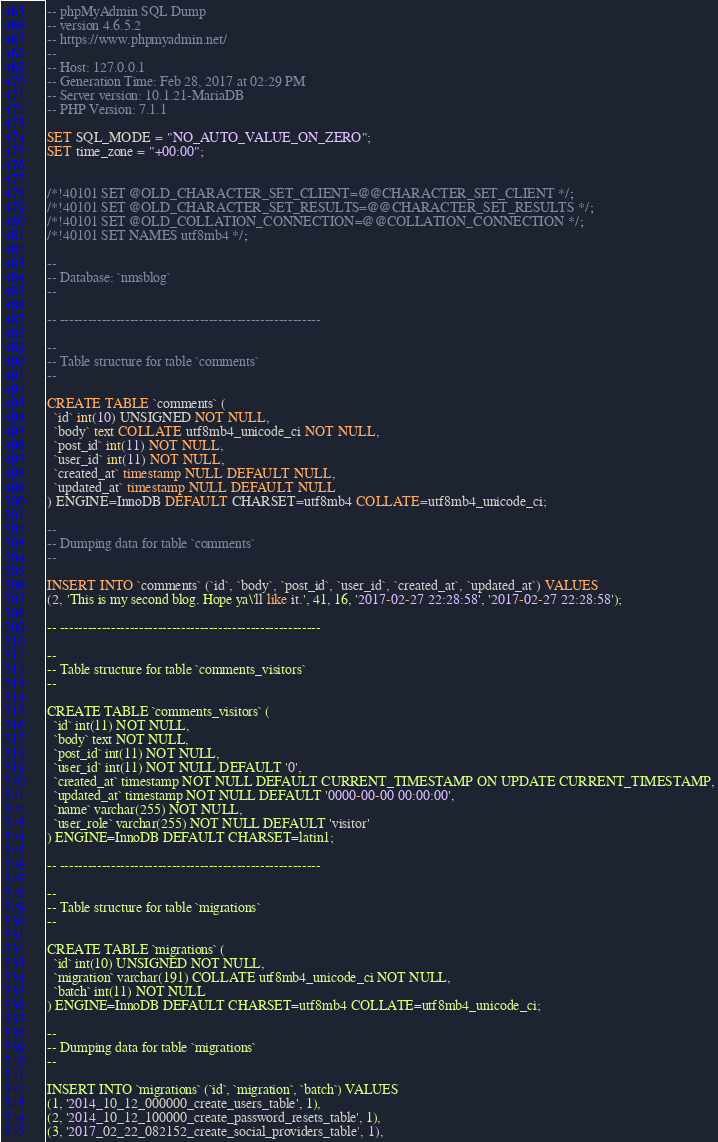Convert code to text. <code><loc_0><loc_0><loc_500><loc_500><_SQL_>-- phpMyAdmin SQL Dump
-- version 4.6.5.2
-- https://www.phpmyadmin.net/
--
-- Host: 127.0.0.1
-- Generation Time: Feb 28, 2017 at 02:29 PM
-- Server version: 10.1.21-MariaDB
-- PHP Version: 7.1.1

SET SQL_MODE = "NO_AUTO_VALUE_ON_ZERO";
SET time_zone = "+00:00";


/*!40101 SET @OLD_CHARACTER_SET_CLIENT=@@CHARACTER_SET_CLIENT */;
/*!40101 SET @OLD_CHARACTER_SET_RESULTS=@@CHARACTER_SET_RESULTS */;
/*!40101 SET @OLD_COLLATION_CONNECTION=@@COLLATION_CONNECTION */;
/*!40101 SET NAMES utf8mb4 */;

--
-- Database: `nmsblog`
--

-- --------------------------------------------------------

--
-- Table structure for table `comments`
--

CREATE TABLE `comments` (
  `id` int(10) UNSIGNED NOT NULL,
  `body` text COLLATE utf8mb4_unicode_ci NOT NULL,
  `post_id` int(11) NOT NULL,
  `user_id` int(11) NOT NULL,
  `created_at` timestamp NULL DEFAULT NULL,
  `updated_at` timestamp NULL DEFAULT NULL
) ENGINE=InnoDB DEFAULT CHARSET=utf8mb4 COLLATE=utf8mb4_unicode_ci;

--
-- Dumping data for table `comments`
--

INSERT INTO `comments` (`id`, `body`, `post_id`, `user_id`, `created_at`, `updated_at`) VALUES
(2, 'This is my second blog. Hope ya\'ll like it.', 41, 16, '2017-02-27 22:28:58', '2017-02-27 22:28:58');

-- --------------------------------------------------------

--
-- Table structure for table `comments_visitors`
--

CREATE TABLE `comments_visitors` (
  `id` int(11) NOT NULL,
  `body` text NOT NULL,
  `post_id` int(11) NOT NULL,
  `user_id` int(11) NOT NULL DEFAULT '0',
  `created_at` timestamp NOT NULL DEFAULT CURRENT_TIMESTAMP ON UPDATE CURRENT_TIMESTAMP,
  `updated_at` timestamp NOT NULL DEFAULT '0000-00-00 00:00:00',
  `name` varchar(255) NOT NULL,
  `user_role` varchar(255) NOT NULL DEFAULT 'visitor'
) ENGINE=InnoDB DEFAULT CHARSET=latin1;

-- --------------------------------------------------------

--
-- Table structure for table `migrations`
--

CREATE TABLE `migrations` (
  `id` int(10) UNSIGNED NOT NULL,
  `migration` varchar(191) COLLATE utf8mb4_unicode_ci NOT NULL,
  `batch` int(11) NOT NULL
) ENGINE=InnoDB DEFAULT CHARSET=utf8mb4 COLLATE=utf8mb4_unicode_ci;

--
-- Dumping data for table `migrations`
--

INSERT INTO `migrations` (`id`, `migration`, `batch`) VALUES
(1, '2014_10_12_000000_create_users_table', 1),
(2, '2014_10_12_100000_create_password_resets_table', 1),
(3, '2017_02_22_082152_create_social_providers_table', 1),</code> 